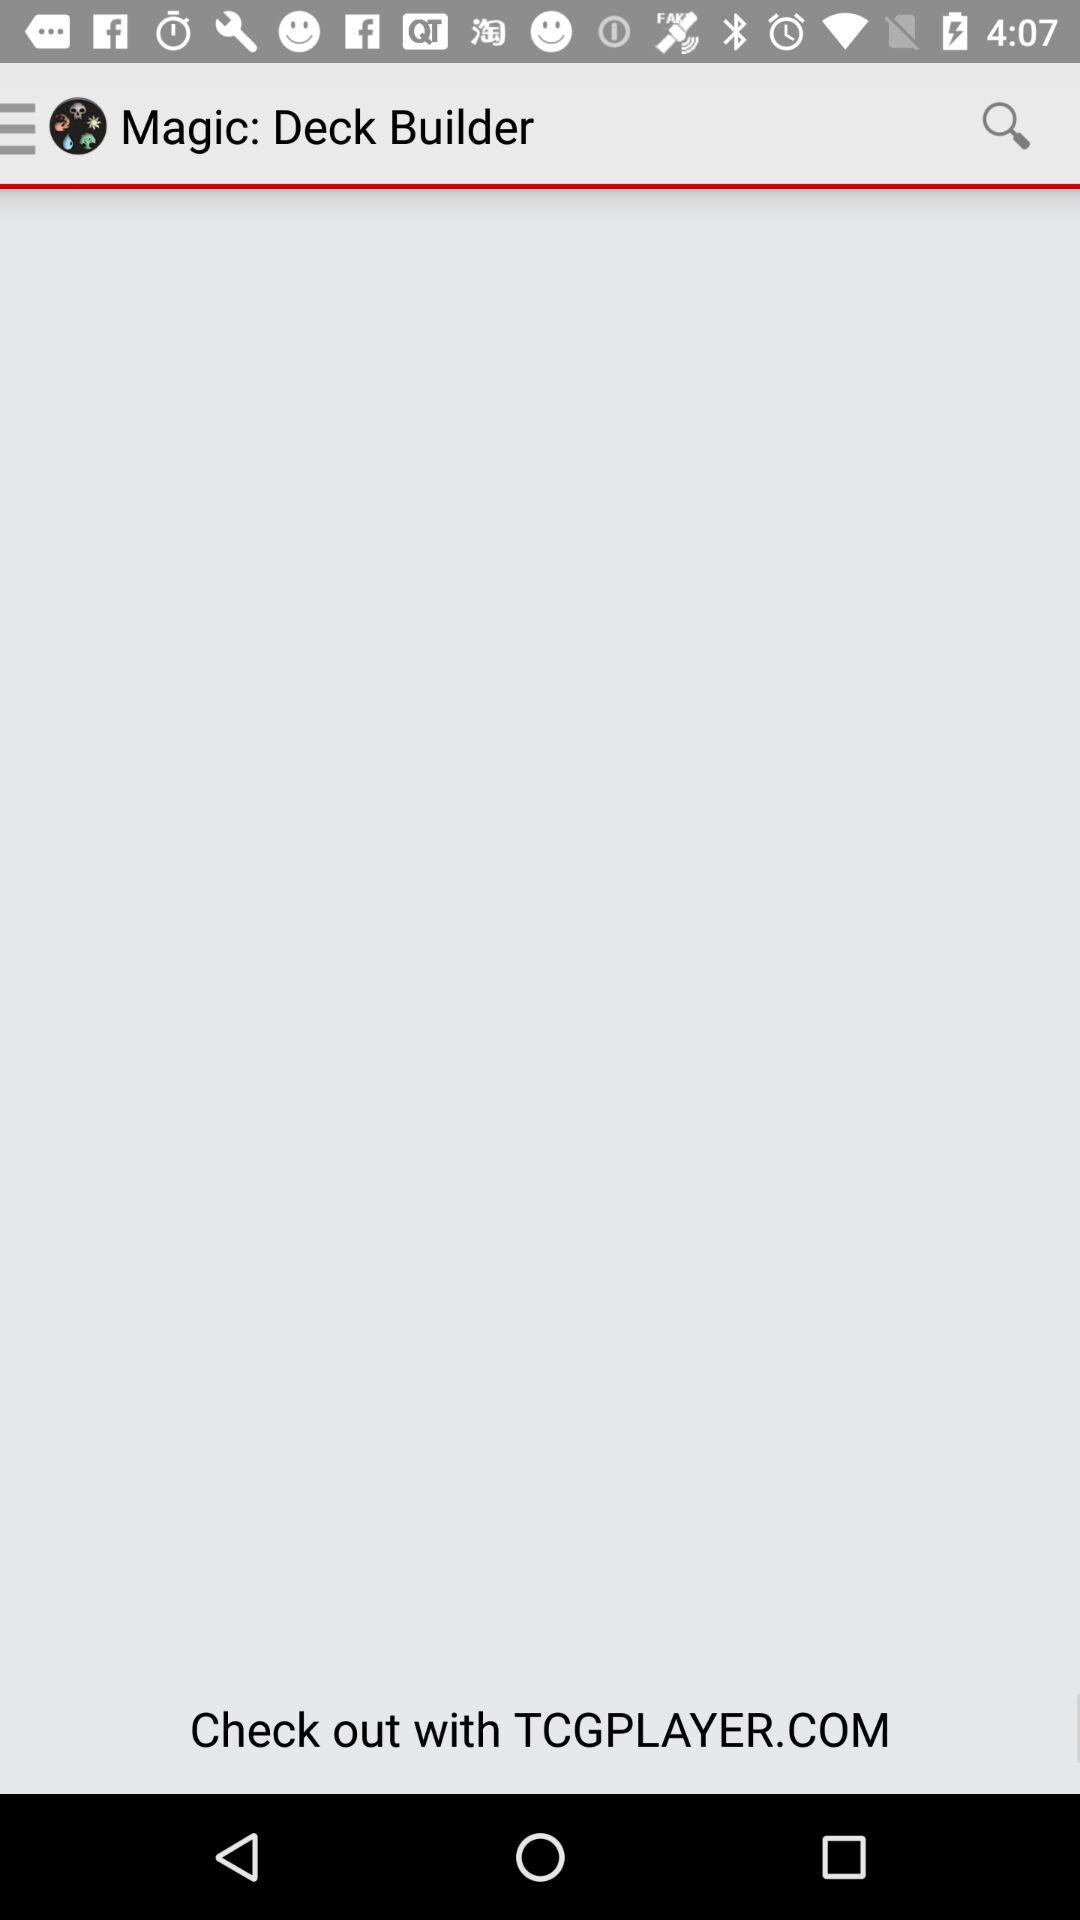Which page are we currently on? You are currently on the first page. 